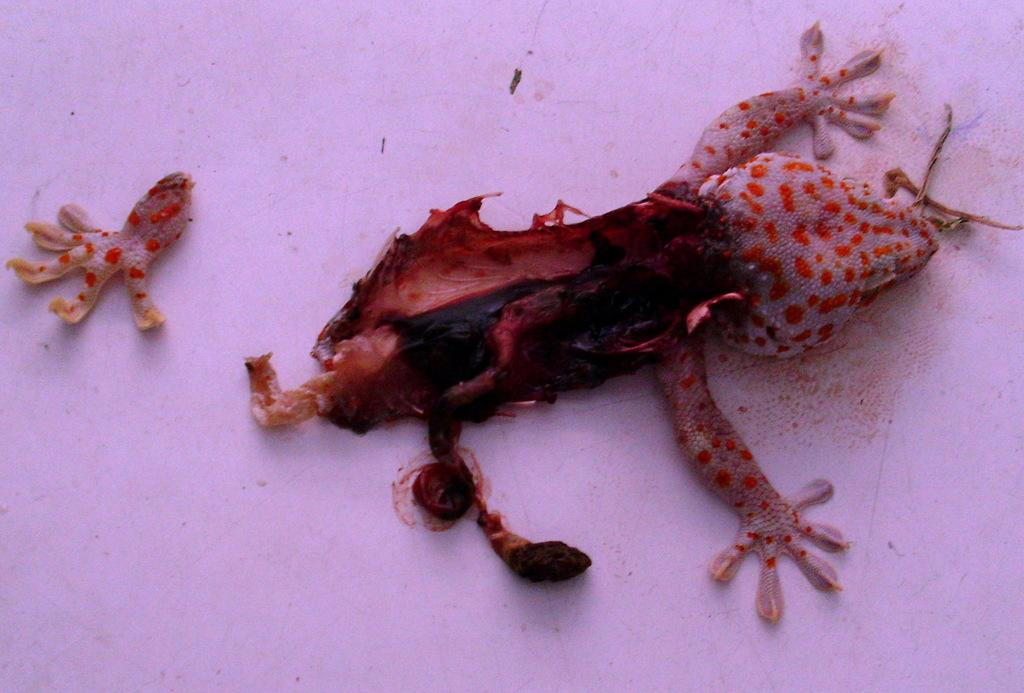What type of animal is in the image? There is a lizard in the image. What is the condition of the lizard? The lizard is partially broken. What color is the floor where the lizard is located? The lizard is on a white color floor. What specific part of the lizard is broken? The lizard has a broken leg. What color is the background of the image? The background of the image is white in color. What date is circled on the calendar in the image? There is no calendar present in the image; it features a lizard with a broken leg on a white floor. What advice does the grandfather give to the lizard in the image? There is no grandfather or any dialogue present in the image; it only shows a lizard with a broken leg on a white floor. 